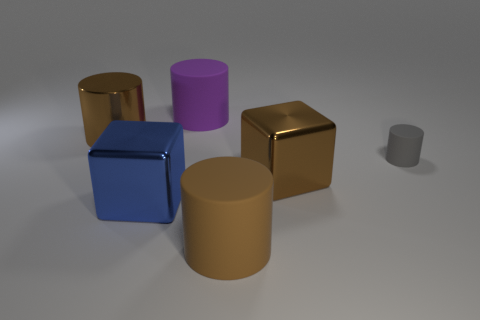Add 1 large yellow cubes. How many objects exist? 7 Subtract all cylinders. How many objects are left? 2 Subtract all tiny yellow cylinders. Subtract all large brown cubes. How many objects are left? 5 Add 4 small matte objects. How many small matte objects are left? 5 Add 1 brown matte things. How many brown matte things exist? 2 Subtract 1 brown blocks. How many objects are left? 5 